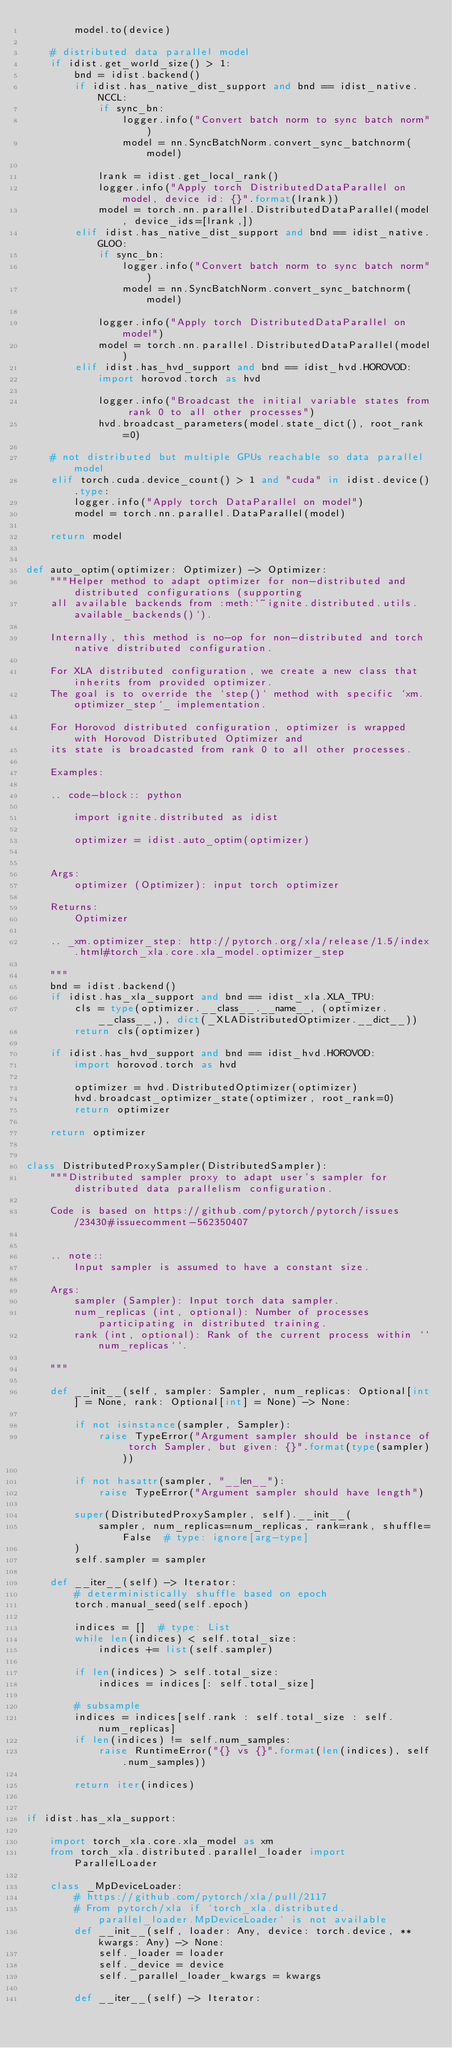<code> <loc_0><loc_0><loc_500><loc_500><_Python_>        model.to(device)

    # distributed data parallel model
    if idist.get_world_size() > 1:
        bnd = idist.backend()
        if idist.has_native_dist_support and bnd == idist_native.NCCL:
            if sync_bn:
                logger.info("Convert batch norm to sync batch norm")
                model = nn.SyncBatchNorm.convert_sync_batchnorm(model)

            lrank = idist.get_local_rank()
            logger.info("Apply torch DistributedDataParallel on model, device id: {}".format(lrank))
            model = torch.nn.parallel.DistributedDataParallel(model, device_ids=[lrank,])
        elif idist.has_native_dist_support and bnd == idist_native.GLOO:
            if sync_bn:
                logger.info("Convert batch norm to sync batch norm")
                model = nn.SyncBatchNorm.convert_sync_batchnorm(model)

            logger.info("Apply torch DistributedDataParallel on model")
            model = torch.nn.parallel.DistributedDataParallel(model)
        elif idist.has_hvd_support and bnd == idist_hvd.HOROVOD:
            import horovod.torch as hvd

            logger.info("Broadcast the initial variable states from rank 0 to all other processes")
            hvd.broadcast_parameters(model.state_dict(), root_rank=0)

    # not distributed but multiple GPUs reachable so data parallel model
    elif torch.cuda.device_count() > 1 and "cuda" in idist.device().type:
        logger.info("Apply torch DataParallel on model")
        model = torch.nn.parallel.DataParallel(model)

    return model


def auto_optim(optimizer: Optimizer) -> Optimizer:
    """Helper method to adapt optimizer for non-distributed and distributed configurations (supporting
    all available backends from :meth:`~ignite.distributed.utils.available_backends()`).

    Internally, this method is no-op for non-distributed and torch native distributed configuration.

    For XLA distributed configuration, we create a new class that inherits from provided optimizer.
    The goal is to override the `step()` method with specific `xm.optimizer_step`_ implementation.

    For Horovod distributed configuration, optimizer is wrapped with Horovod Distributed Optimizer and
    its state is broadcasted from rank 0 to all other processes.

    Examples:

    .. code-block:: python

        import ignite.distributed as idist

        optimizer = idist.auto_optim(optimizer)


    Args:
        optimizer (Optimizer): input torch optimizer

    Returns:
        Optimizer

    .. _xm.optimizer_step: http://pytorch.org/xla/release/1.5/index.html#torch_xla.core.xla_model.optimizer_step

    """
    bnd = idist.backend()
    if idist.has_xla_support and bnd == idist_xla.XLA_TPU:
        cls = type(optimizer.__class__.__name__, (optimizer.__class__,), dict(_XLADistributedOptimizer.__dict__))
        return cls(optimizer)

    if idist.has_hvd_support and bnd == idist_hvd.HOROVOD:
        import horovod.torch as hvd

        optimizer = hvd.DistributedOptimizer(optimizer)
        hvd.broadcast_optimizer_state(optimizer, root_rank=0)
        return optimizer

    return optimizer


class DistributedProxySampler(DistributedSampler):
    """Distributed sampler proxy to adapt user's sampler for distributed data parallelism configuration.

    Code is based on https://github.com/pytorch/pytorch/issues/23430#issuecomment-562350407


    .. note::
        Input sampler is assumed to have a constant size.

    Args:
        sampler (Sampler): Input torch data sampler.
        num_replicas (int, optional): Number of processes participating in distributed training.
        rank (int, optional): Rank of the current process within ``num_replicas``.

    """

    def __init__(self, sampler: Sampler, num_replicas: Optional[int] = None, rank: Optional[int] = None) -> None:

        if not isinstance(sampler, Sampler):
            raise TypeError("Argument sampler should be instance of torch Sampler, but given: {}".format(type(sampler)))

        if not hasattr(sampler, "__len__"):
            raise TypeError("Argument sampler should have length")

        super(DistributedProxySampler, self).__init__(
            sampler, num_replicas=num_replicas, rank=rank, shuffle=False  # type: ignore[arg-type]
        )
        self.sampler = sampler

    def __iter__(self) -> Iterator:
        # deterministically shuffle based on epoch
        torch.manual_seed(self.epoch)

        indices = []  # type: List
        while len(indices) < self.total_size:
            indices += list(self.sampler)

        if len(indices) > self.total_size:
            indices = indices[: self.total_size]

        # subsample
        indices = indices[self.rank : self.total_size : self.num_replicas]
        if len(indices) != self.num_samples:
            raise RuntimeError("{} vs {}".format(len(indices), self.num_samples))

        return iter(indices)


if idist.has_xla_support:

    import torch_xla.core.xla_model as xm
    from torch_xla.distributed.parallel_loader import ParallelLoader

    class _MpDeviceLoader:
        # https://github.com/pytorch/xla/pull/2117
        # From pytorch/xla if `torch_xla.distributed.parallel_loader.MpDeviceLoader` is not available
        def __init__(self, loader: Any, device: torch.device, **kwargs: Any) -> None:
            self._loader = loader
            self._device = device
            self._parallel_loader_kwargs = kwargs

        def __iter__(self) -> Iterator:</code> 